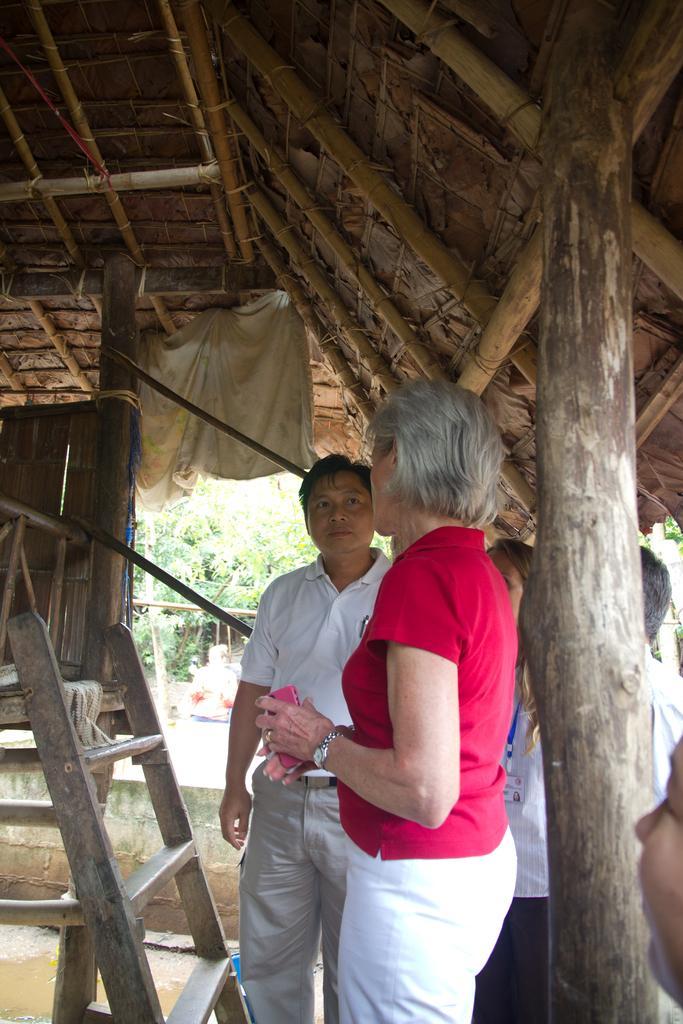How would you summarize this image in a sentence or two? In this image we can see a man and a woman standing under a roof. We can also see a ladder and a cloth which is tied to a roof. On the backside we can see some trees and a wall. 